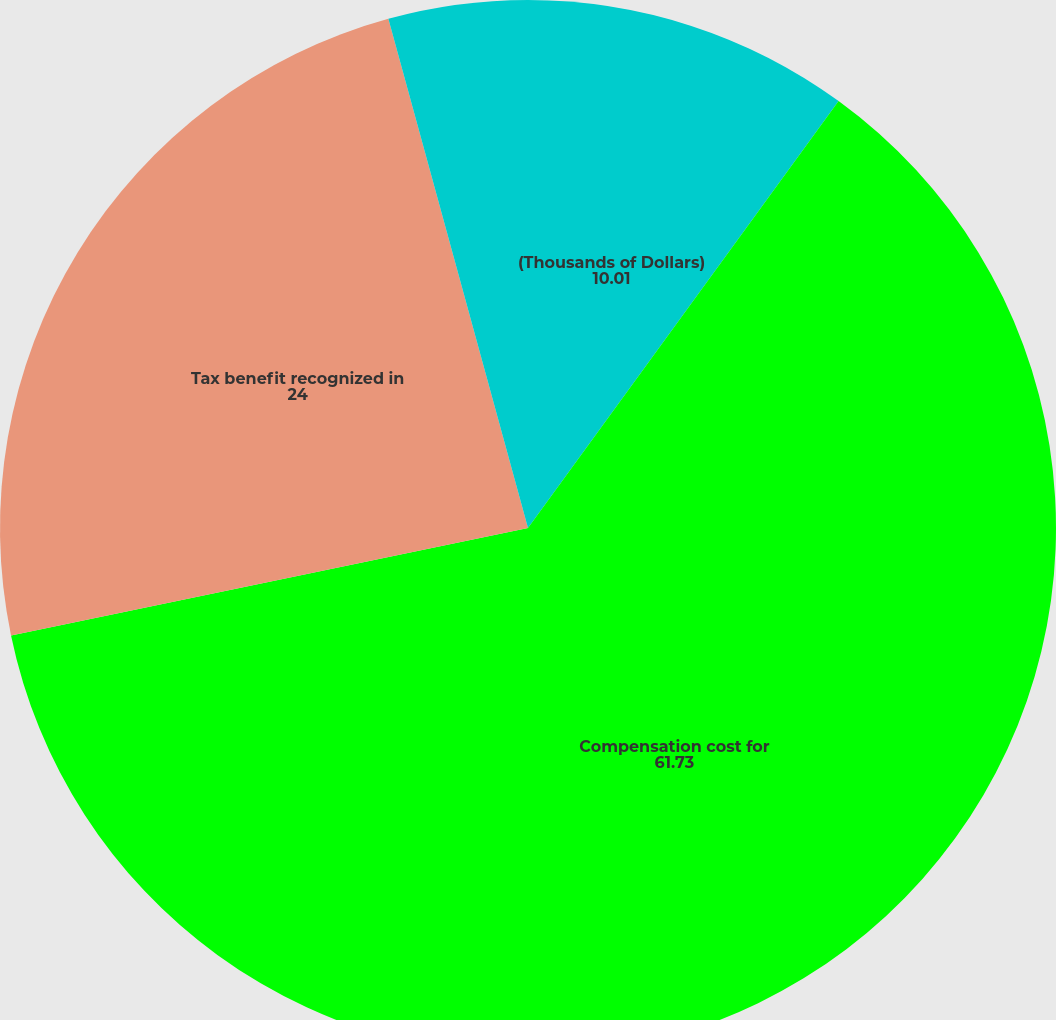<chart> <loc_0><loc_0><loc_500><loc_500><pie_chart><fcel>(Thousands of Dollars)<fcel>Compensation cost for<fcel>Tax benefit recognized in<fcel>Capitalized compensation cost<nl><fcel>10.01%<fcel>61.73%<fcel>24.0%<fcel>4.26%<nl></chart> 